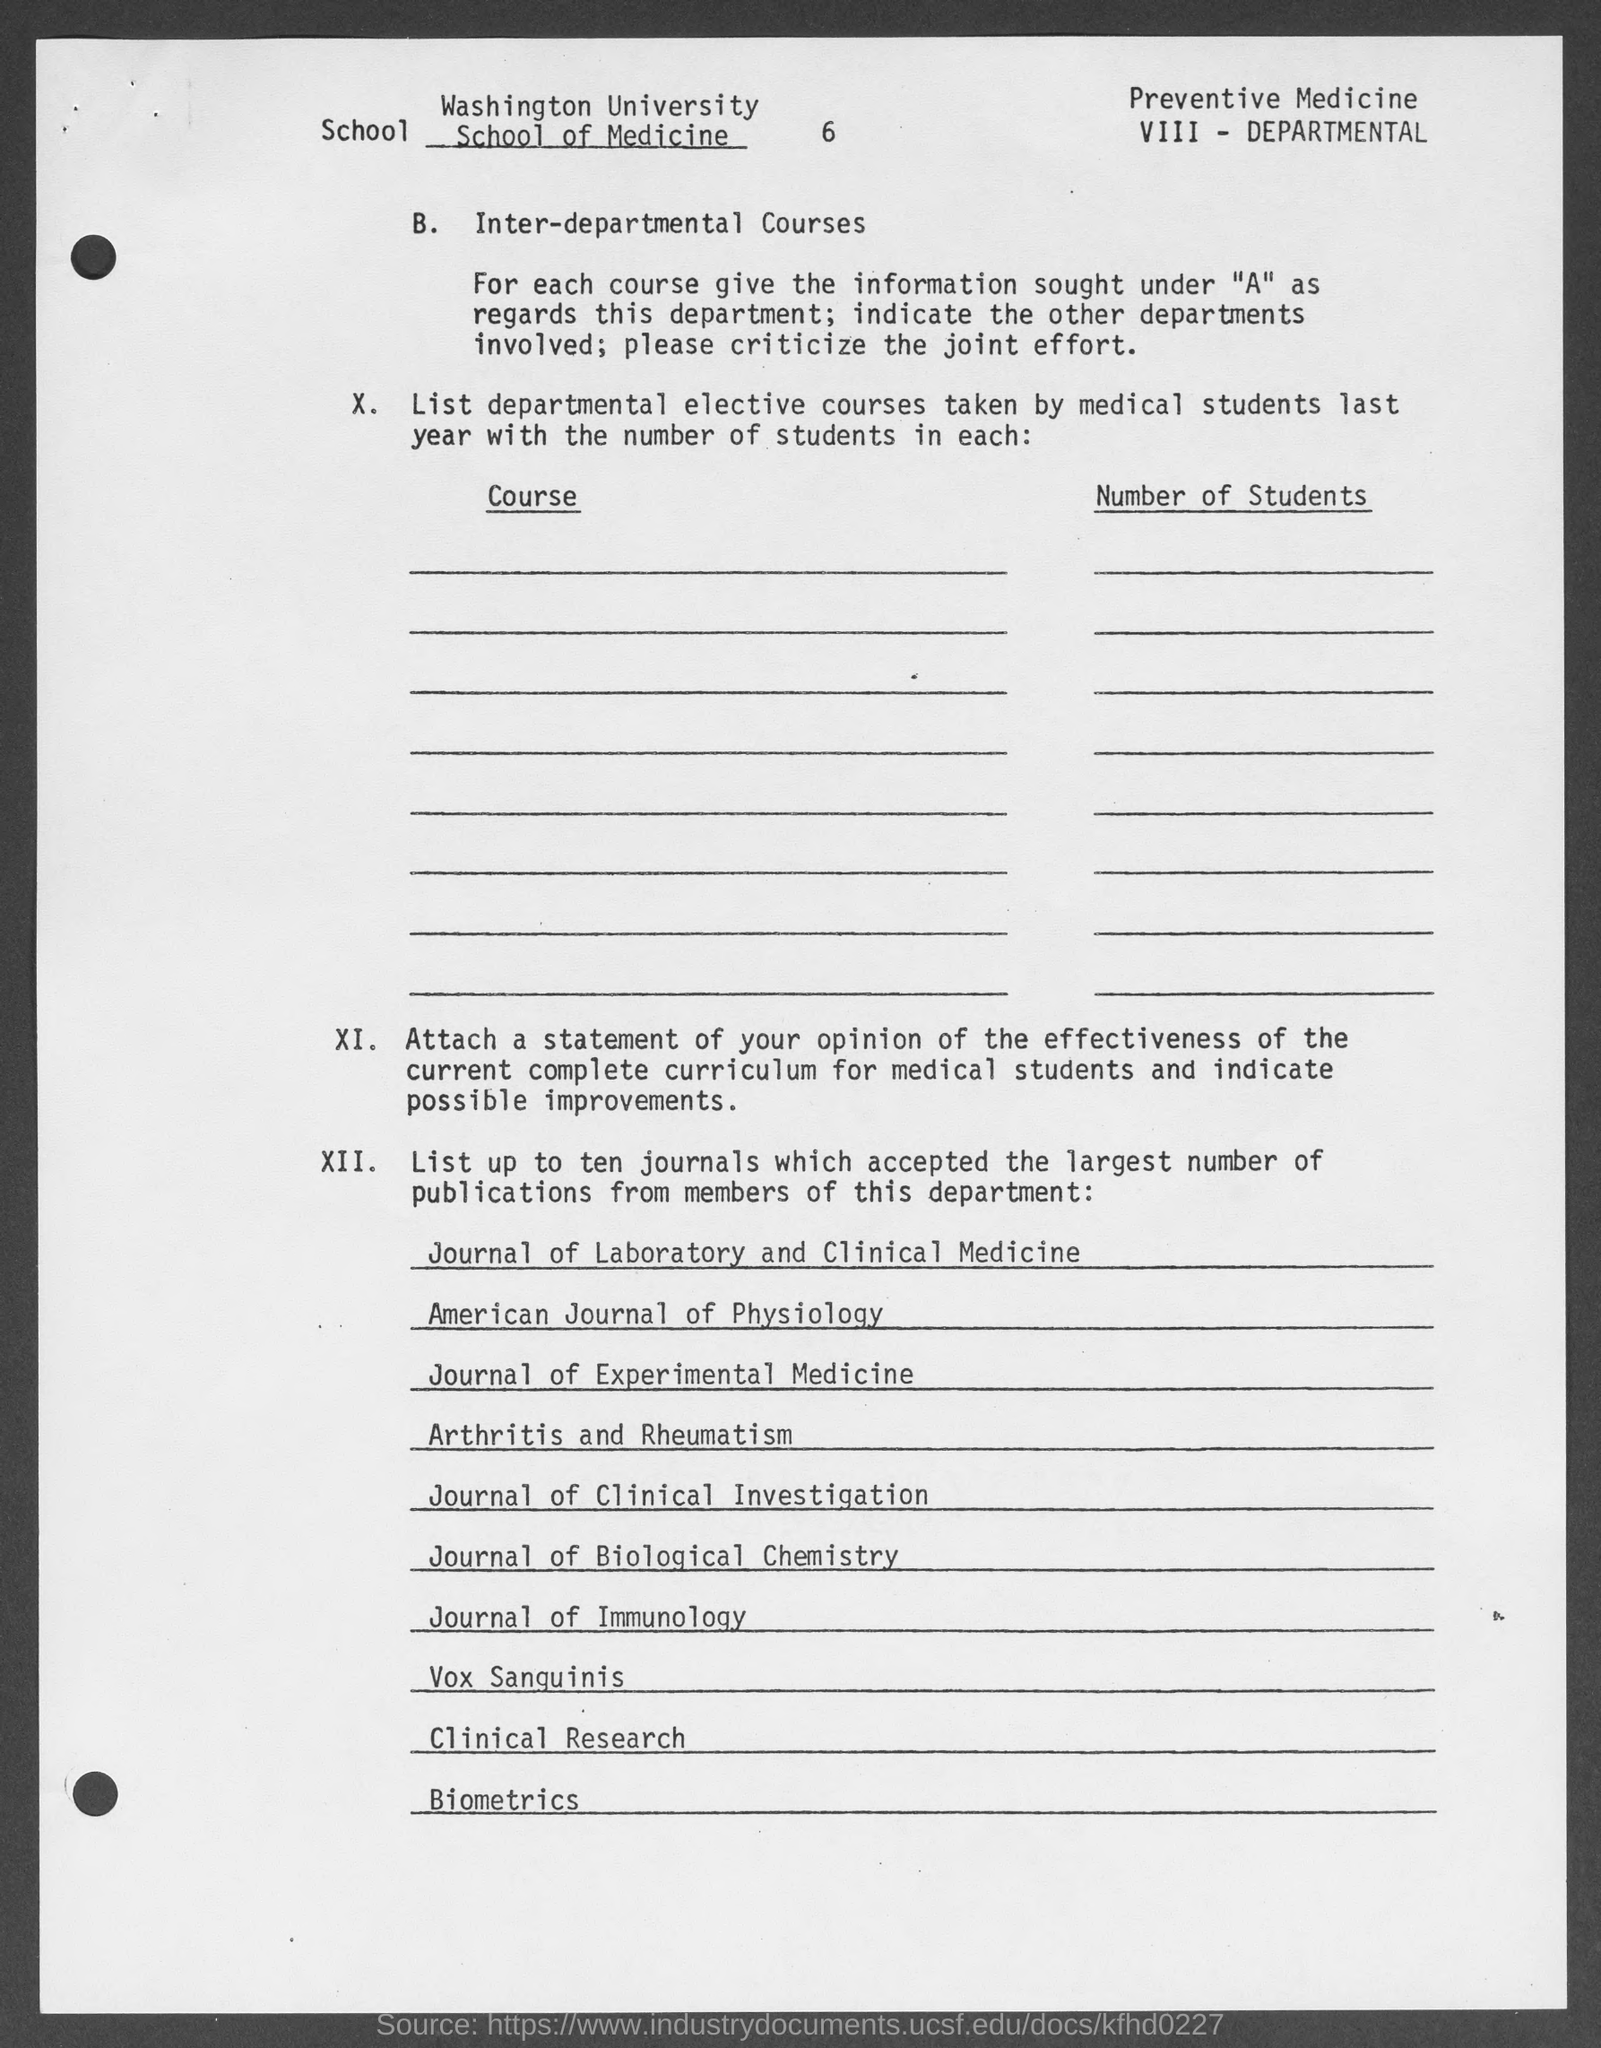Specify some key components in this picture. The number at the top of the document is 6. 